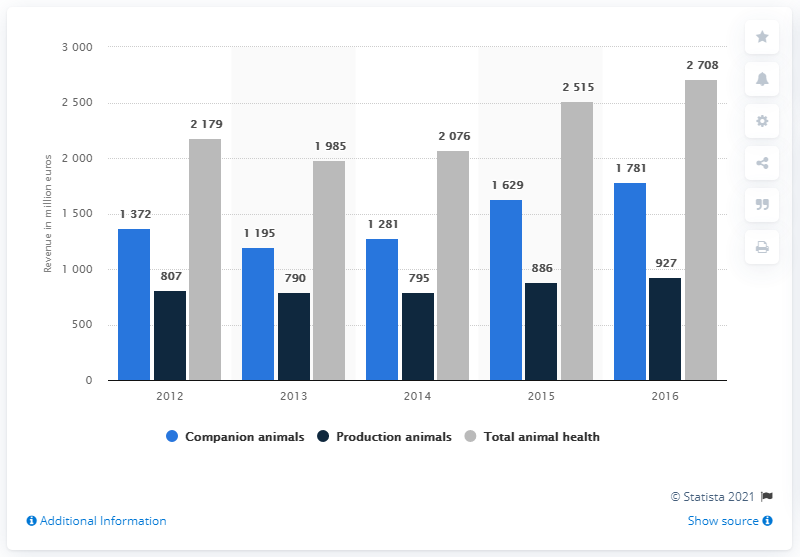Point out several critical features in this image. The color navy blue indicates the production of animals. The average production of animals is 841. 